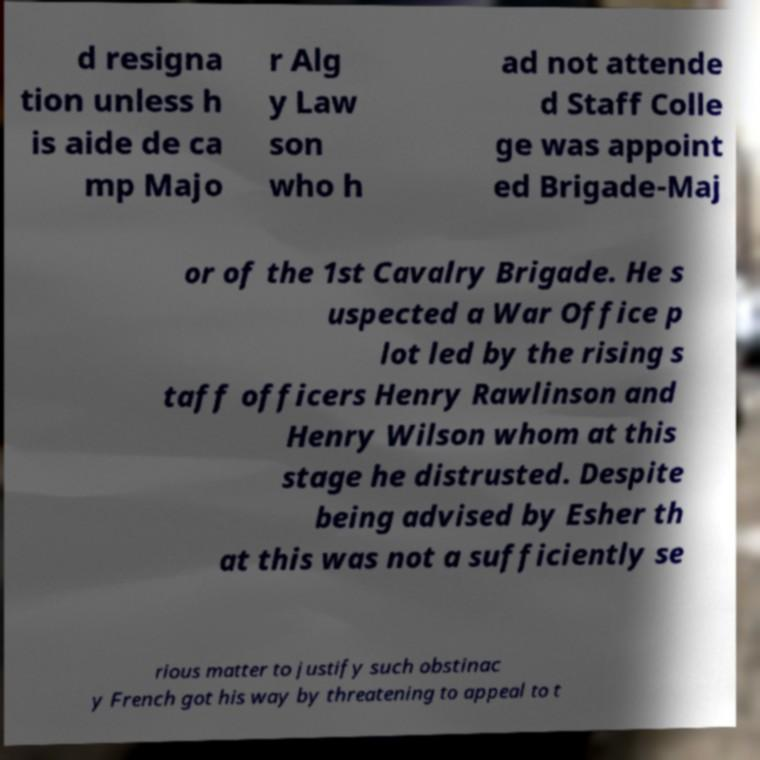For documentation purposes, I need the text within this image transcribed. Could you provide that? d resigna tion unless h is aide de ca mp Majo r Alg y Law son who h ad not attende d Staff Colle ge was appoint ed Brigade-Maj or of the 1st Cavalry Brigade. He s uspected a War Office p lot led by the rising s taff officers Henry Rawlinson and Henry Wilson whom at this stage he distrusted. Despite being advised by Esher th at this was not a sufficiently se rious matter to justify such obstinac y French got his way by threatening to appeal to t 